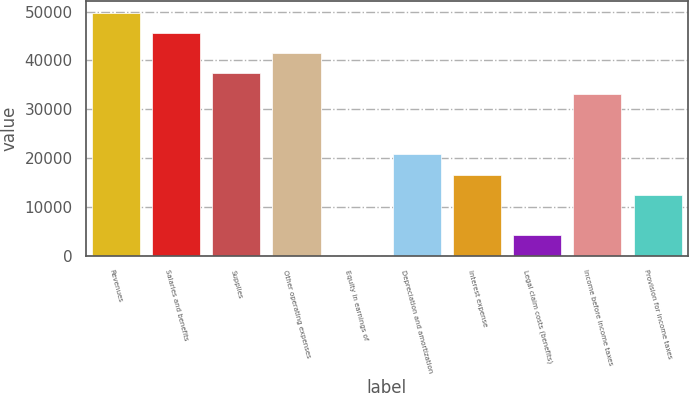Convert chart to OTSL. <chart><loc_0><loc_0><loc_500><loc_500><bar_chart><fcel>Revenues<fcel>Salaries and benefits<fcel>Supplies<fcel>Other operating expenses<fcel>Equity in earnings of<fcel>Depreciation and amortization<fcel>Interest expense<fcel>Legal claim costs (benefits)<fcel>Income before income taxes<fcel>Provision for income taxes<nl><fcel>49777.2<fcel>45633.6<fcel>37346.4<fcel>41490<fcel>54<fcel>20772<fcel>16628.4<fcel>4197.6<fcel>33202.8<fcel>12484.8<nl></chart> 